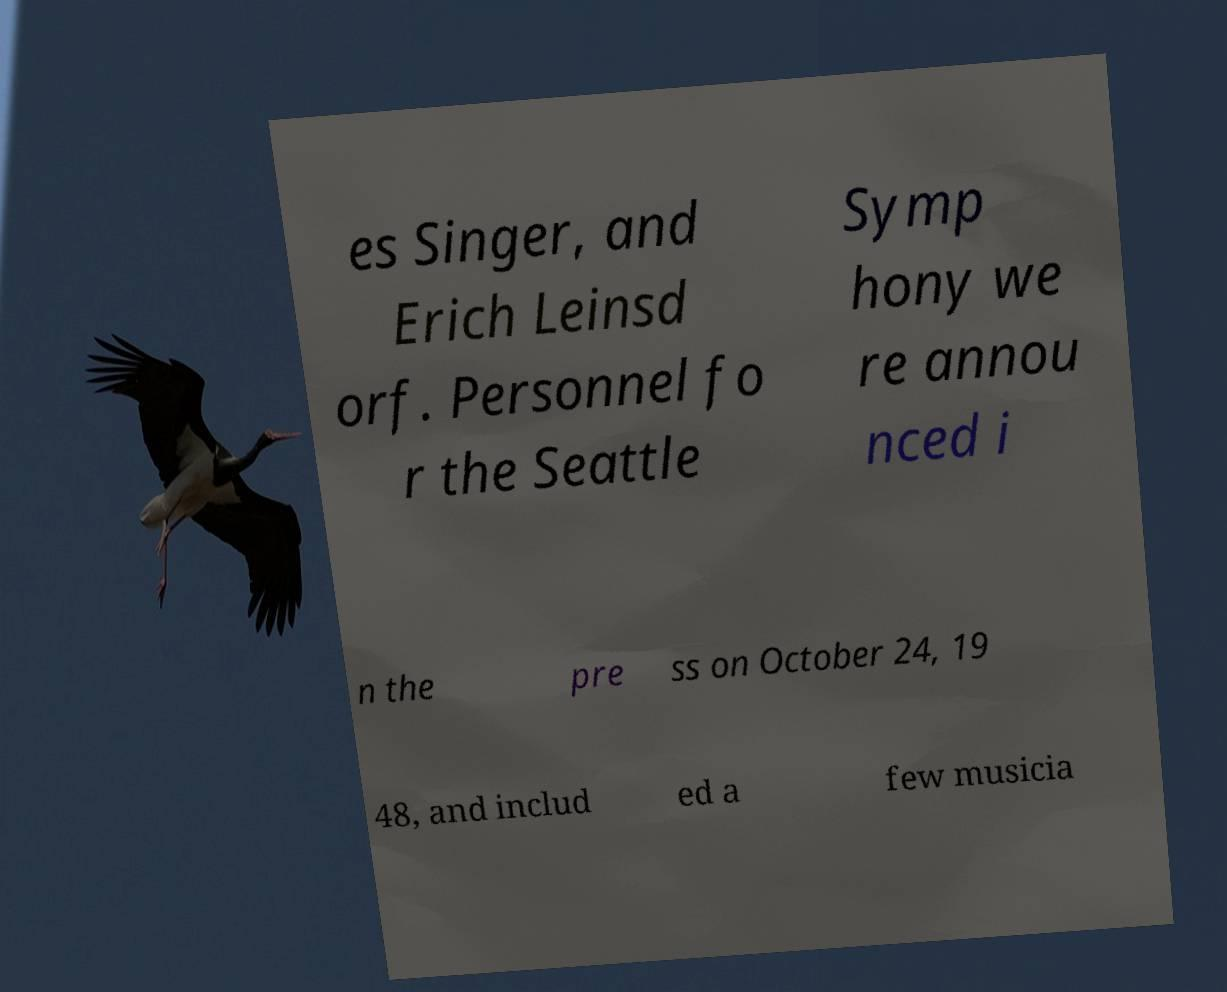Can you accurately transcribe the text from the provided image for me? es Singer, and Erich Leinsd orf. Personnel fo r the Seattle Symp hony we re annou nced i n the pre ss on October 24, 19 48, and includ ed a few musicia 